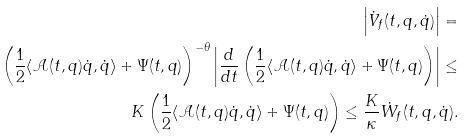<formula> <loc_0><loc_0><loc_500><loc_500>\left | \dot { V } _ { f } ( t , q , \dot { q } ) \right | = \\ \left ( \frac { 1 } { 2 } \langle \mathcal { A } ( t , q ) \dot { q } , \dot { q } \rangle + \Psi ( t , q ) \right ) ^ { - \theta } \left | \frac { d } { d t } \left ( \frac { 1 } { 2 } \langle \mathcal { A } ( t , q ) \dot { q } , \dot { q } \rangle + \Psi ( t , q ) \right ) \right | \leq \\ K \left ( \frac { 1 } { 2 } \langle \mathcal { A } ( t , q ) \dot { q } , \dot { q } \rangle + \Psi ( t , q ) \right ) \leq \frac { K } { \kappa } \dot { W } _ { f } ( t , q , \dot { q } ) .</formula> 